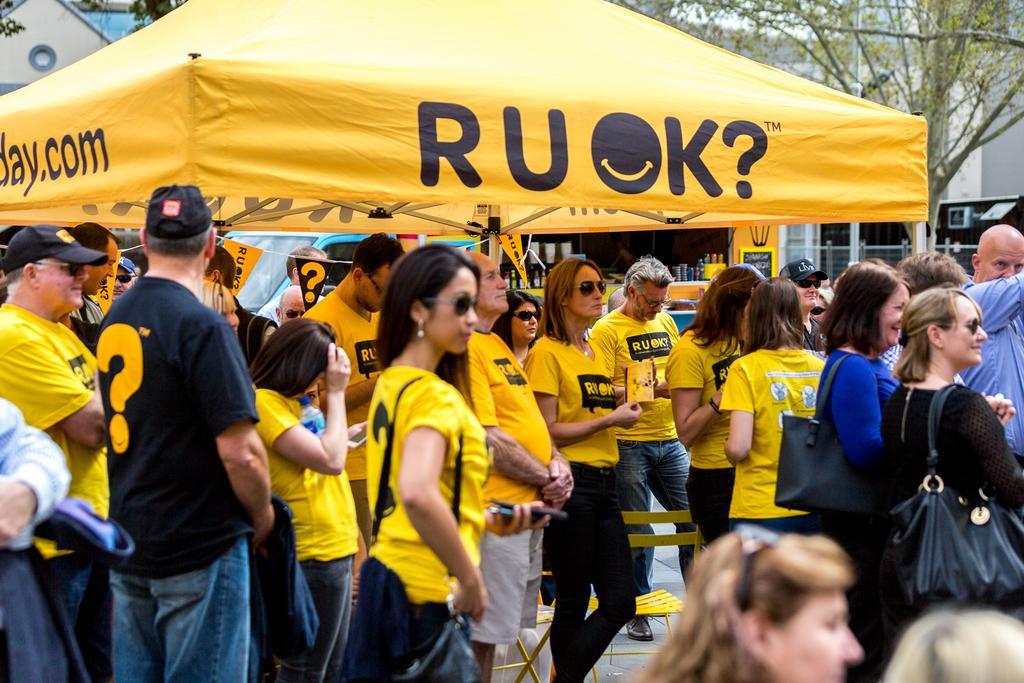In one or two sentences, can you explain what this image depicts? Here we can see a group of people. Most of the people wore yellow t-shirts. This is a tent. Background there is a store and trees. In this store there are objects. These two people wore handbags. This woman is holding objects.  